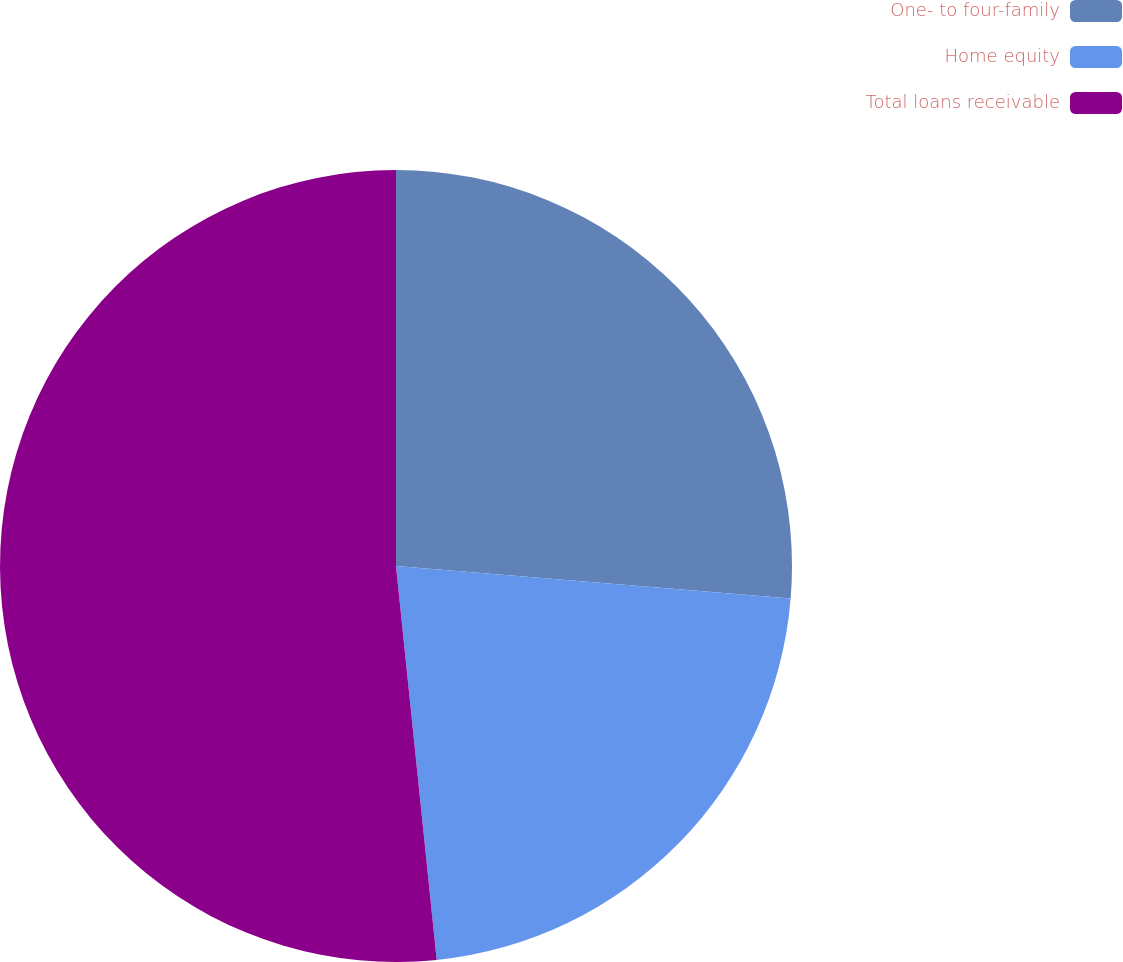Convert chart to OTSL. <chart><loc_0><loc_0><loc_500><loc_500><pie_chart><fcel>One- to four-family<fcel>Home equity<fcel>Total loans receivable<nl><fcel>26.31%<fcel>22.05%<fcel>51.64%<nl></chart> 